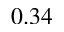Convert formula to latex. <formula><loc_0><loc_0><loc_500><loc_500>0 . 3 4</formula> 